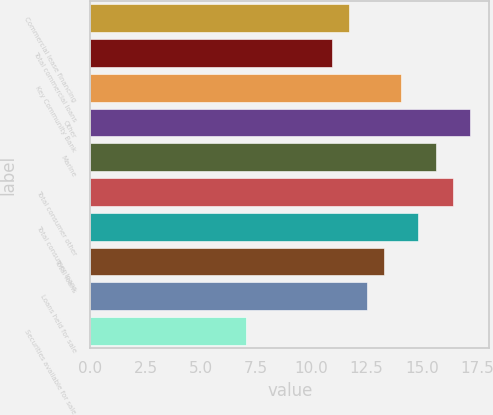<chart> <loc_0><loc_0><loc_500><loc_500><bar_chart><fcel>Commercial lease financing<fcel>Total commercial loans<fcel>Key Community Bank<fcel>Other<fcel>Marine<fcel>Total consumer other<fcel>Total consumer loans<fcel>Total loans<fcel>Loans held for sale<fcel>Securities available for sale<nl><fcel>11.72<fcel>10.94<fcel>14.06<fcel>17.18<fcel>15.62<fcel>16.4<fcel>14.84<fcel>13.28<fcel>12.5<fcel>7.04<nl></chart> 